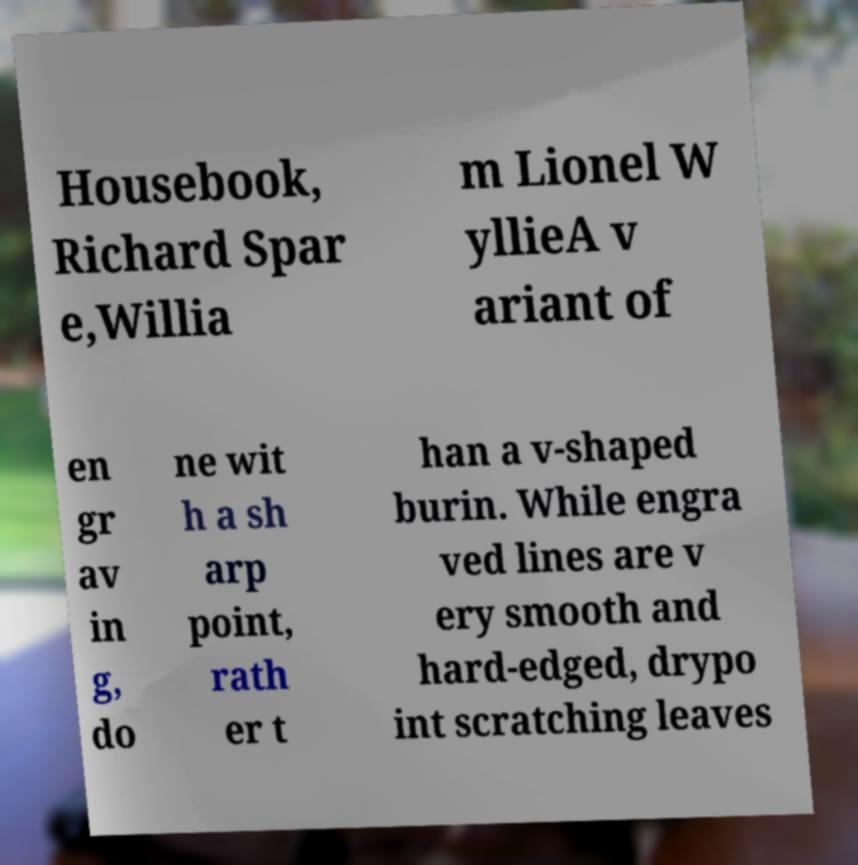Can you accurately transcribe the text from the provided image for me? Housebook, Richard Spar e,Willia m Lionel W yllieA v ariant of en gr av in g, do ne wit h a sh arp point, rath er t han a v-shaped burin. While engra ved lines are v ery smooth and hard-edged, drypo int scratching leaves 